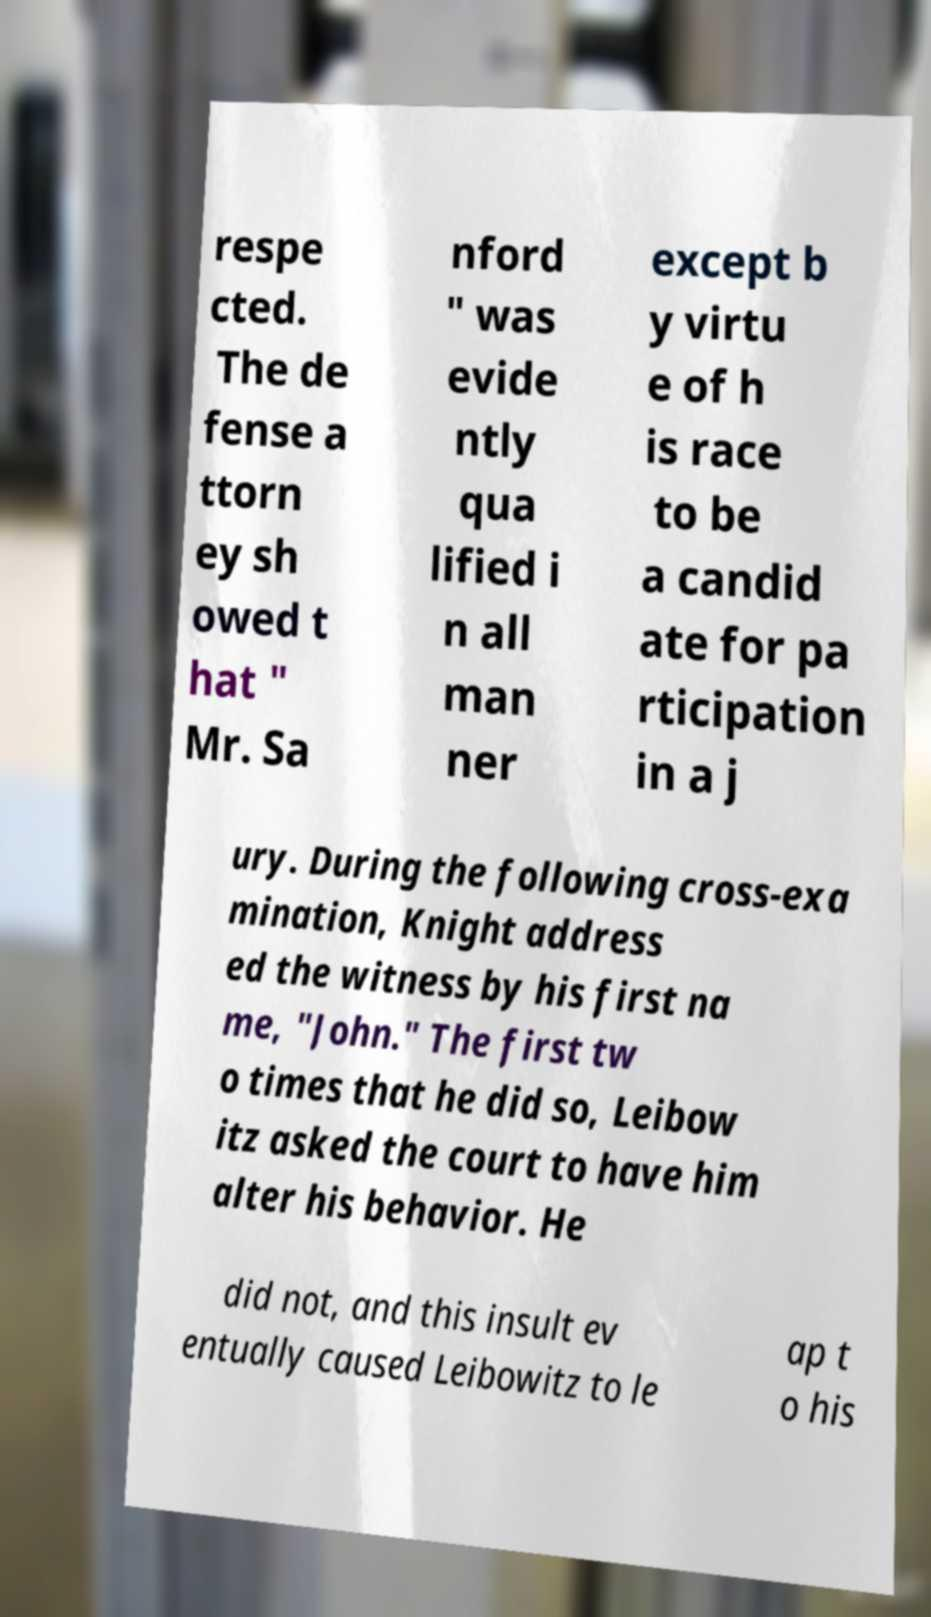For documentation purposes, I need the text within this image transcribed. Could you provide that? respe cted. The de fense a ttorn ey sh owed t hat " Mr. Sa nford " was evide ntly qua lified i n all man ner except b y virtu e of h is race to be a candid ate for pa rticipation in a j ury. During the following cross-exa mination, Knight address ed the witness by his first na me, "John." The first tw o times that he did so, Leibow itz asked the court to have him alter his behavior. He did not, and this insult ev entually caused Leibowitz to le ap t o his 